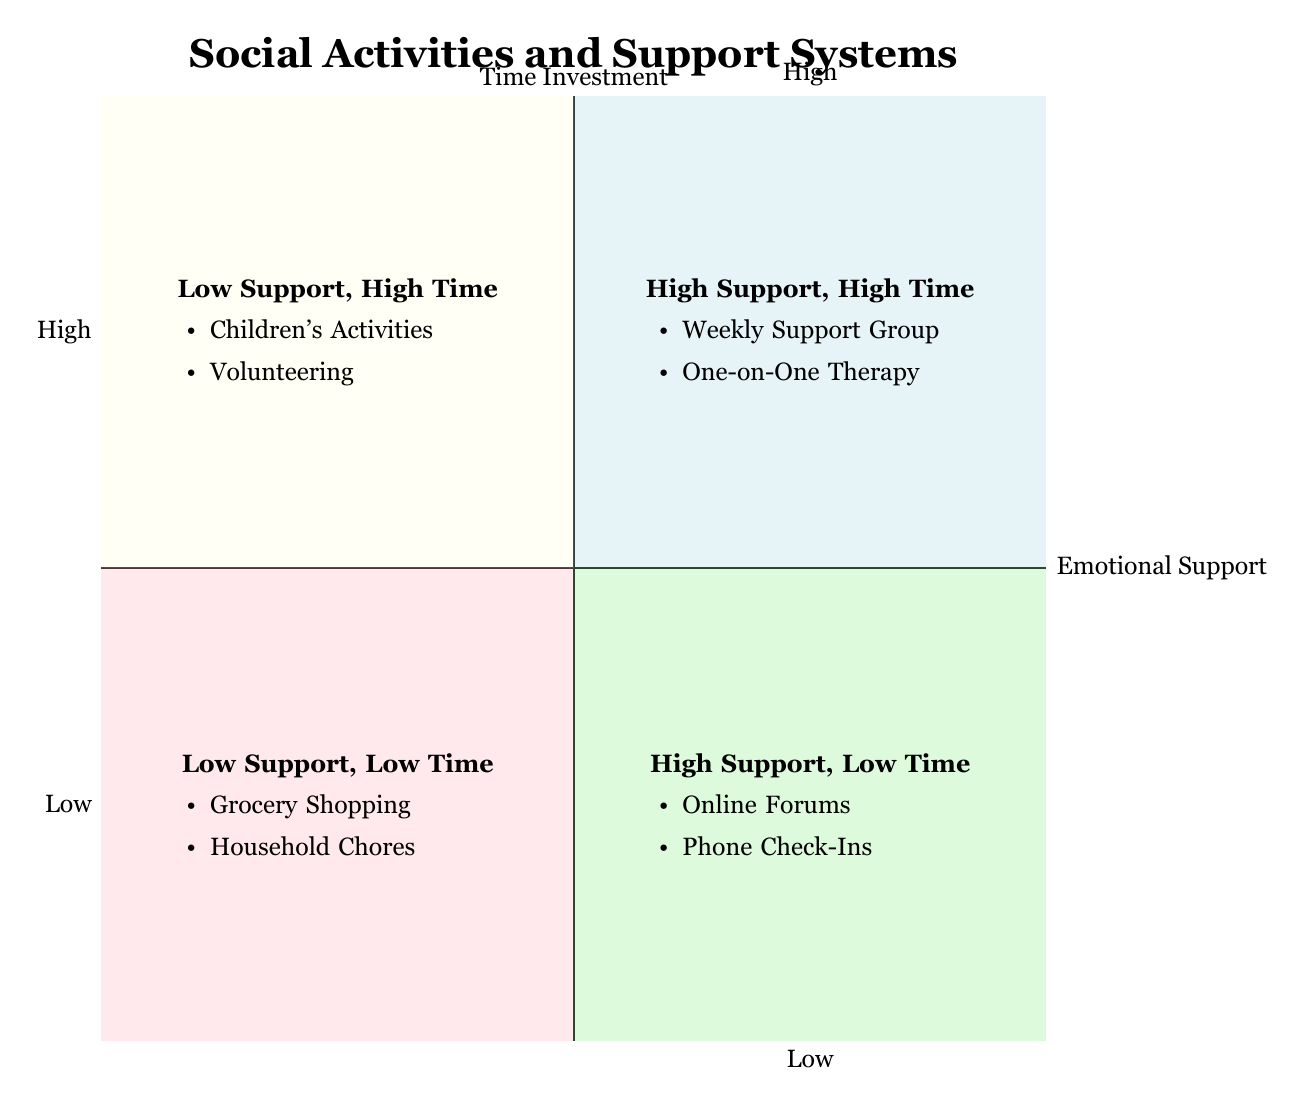What activities fall into the High Support, Low Time quadrant? To answer this, I look at the quadrant labeled "High Support, Low Time." The activities listed in this quadrant are "Online Support Forums" and "Phone Check-Ins with Friends."
Answer: Online Support Forums, Phone Check-Ins with Friends What is the emotional support level for "Children's Extracurricular Activities"? I find the activity "Children's Extracurricular Activities" listed in the "Low Support, High Time" quadrant, indicating that it offers a low level of emotional support.
Answer: Low How many activities provide High Emotional Support? I count the activities listed in both quadrants that indicate high emotional support: "Weekly Support Group for Single Parents," "One-on-One Therapy Sessions," "Online Support Forums," and "Phone Check-Ins with Friends," totaling four activities.
Answer: 4 Which quadrant contains the least time-intensive activities? The quadrant titled "Low Support, Low Time" is where the activities "Weekly Grocery Shopping" and "Household Chores" are located, which are both time-efficient. Therefore, this is the quadrant that contains the least time-intensive activities.
Answer: Low Support, Low Time What is the emotional support classification for "Volunteering in the Community"? I check the quadrant where "Volunteering in the Community" is positioned, which is "Low Support, High Time," meaning it provides low emotional support.
Answer: Low Are there any activities listed under High Emotional Support and High Time? Yes, in the quadrant labeled "High Support, High Time," there are activities such as "Weekly Support Group for Single Parents" and "One-on-One Therapy Sessions," confirming that there are activities in this classification.
Answer: Yes Which activity requires the most time investment? Checking all four quadrants, the activities in "Low Support, High Time" that require significant time investment include "Children's Extracurricular Activities" and "Volunteering in the Community." Particularly, managing children's extracurricular activities typically takes the most time overall.
Answer: Children's Extracurricular Activities What type of support do household chores provide? "Household Chores" fall within the "Low Support, Low Time" quadrant, indicating that they provide low emotional support.
Answer: Low Emotional Support What is the time investment for Phone Check-Ins with Friends? I look at the "High Support, Low Time" quadrant, where "Phone Check-Ins with Friends" is listed, and it is described as taking 10-20 minutes and occurring a few times a week, indicating that it requires low time investment overall.
Answer: Low Time Investment 